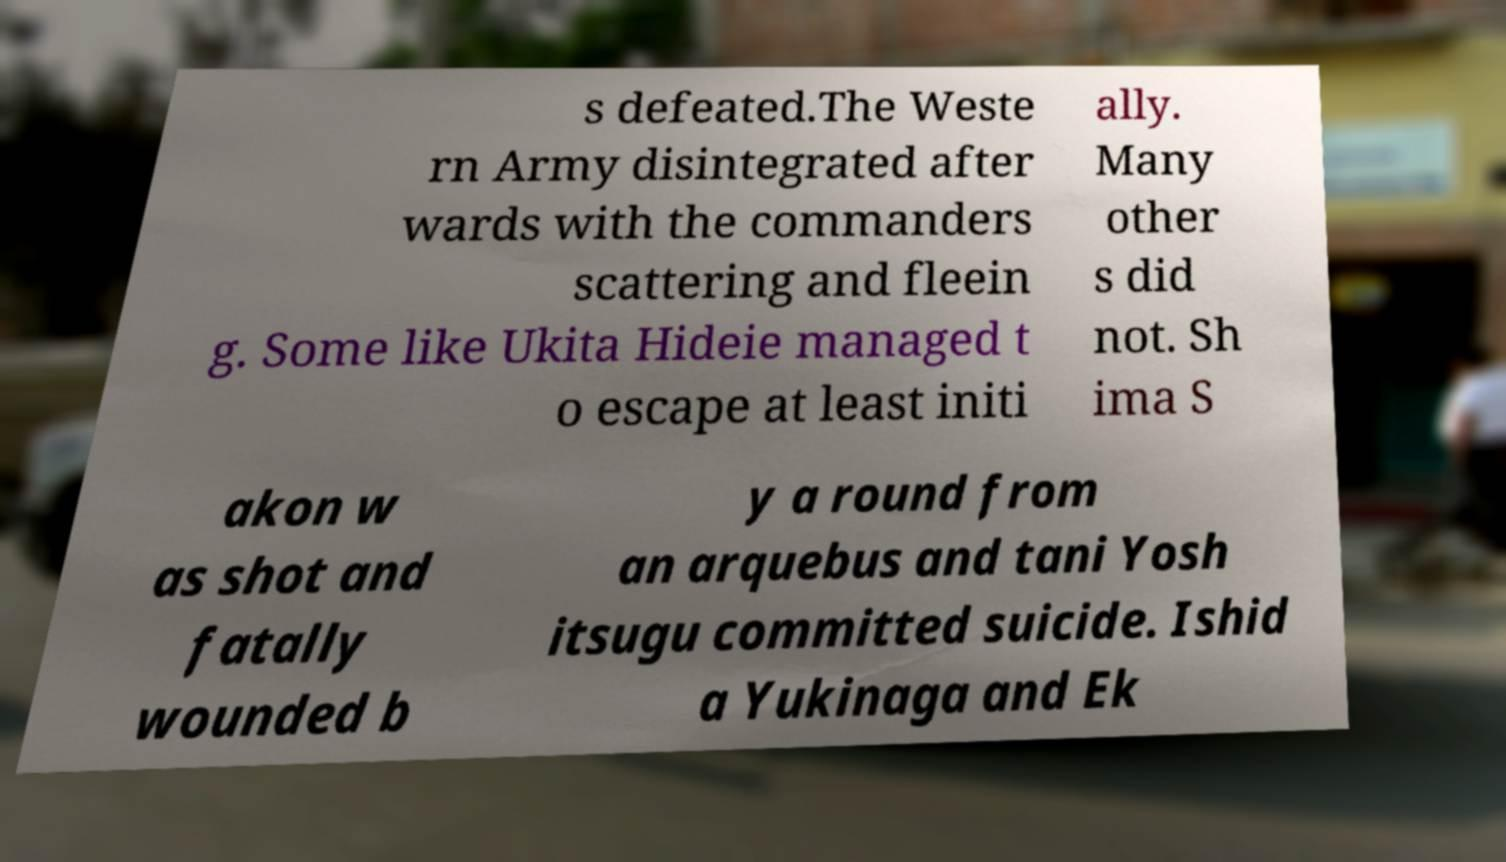What messages or text are displayed in this image? I need them in a readable, typed format. s defeated.The Weste rn Army disintegrated after wards with the commanders scattering and fleein g. Some like Ukita Hideie managed t o escape at least initi ally. Many other s did not. Sh ima S akon w as shot and fatally wounded b y a round from an arquebus and tani Yosh itsugu committed suicide. Ishid a Yukinaga and Ek 